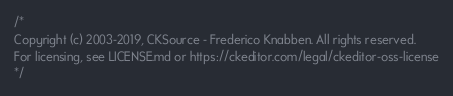Convert code to text. <code><loc_0><loc_0><loc_500><loc_500><_CSS_>/*
Copyright (c) 2003-2019, CKSource - Frederico Knabben. All rights reserved.
For licensing, see LICENSE.md or https://ckeditor.com/legal/ckeditor-oss-license
*/</code> 